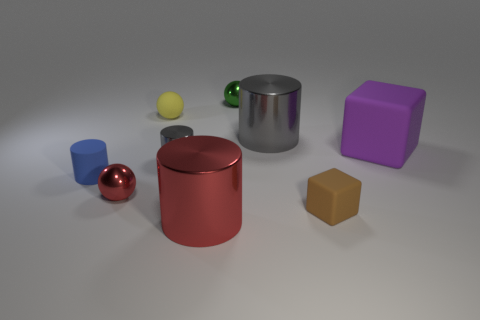Is the number of tiny brown matte objects left of the brown block greater than the number of cylinders behind the tiny gray cylinder?
Your answer should be compact. No. What number of other things are there of the same size as the brown thing?
Your answer should be compact. 5. Does the blue rubber thing have the same shape as the big shiny thing in front of the blue rubber thing?
Provide a succinct answer. Yes. What number of matte objects are either small purple cylinders or purple blocks?
Provide a succinct answer. 1. Are there any large rubber blocks of the same color as the large matte object?
Provide a short and direct response. No. Are there any big gray matte cylinders?
Make the answer very short. No. Is the small gray metal object the same shape as the small blue object?
Keep it short and to the point. Yes. What number of big things are gray blocks or gray cylinders?
Provide a short and direct response. 1. The tiny shiny cylinder has what color?
Make the answer very short. Gray. There is a small metallic thing behind the cube behind the tiny blue thing; what shape is it?
Provide a short and direct response. Sphere. 